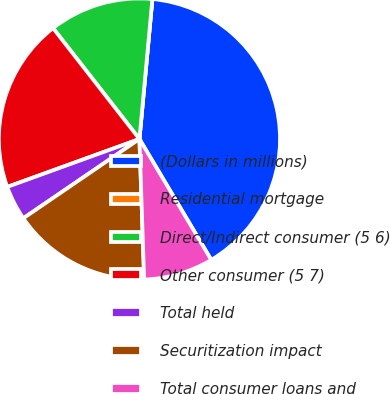Convert chart. <chart><loc_0><loc_0><loc_500><loc_500><pie_chart><fcel>(Dollars in millions)<fcel>Residential mortgage<fcel>Direct/Indirect consumer (5 6)<fcel>Other consumer (5 7)<fcel>Total held<fcel>Securitization impact<fcel>Total consumer loans and<nl><fcel>40.0%<fcel>0.0%<fcel>12.0%<fcel>20.0%<fcel>4.0%<fcel>16.0%<fcel>8.0%<nl></chart> 